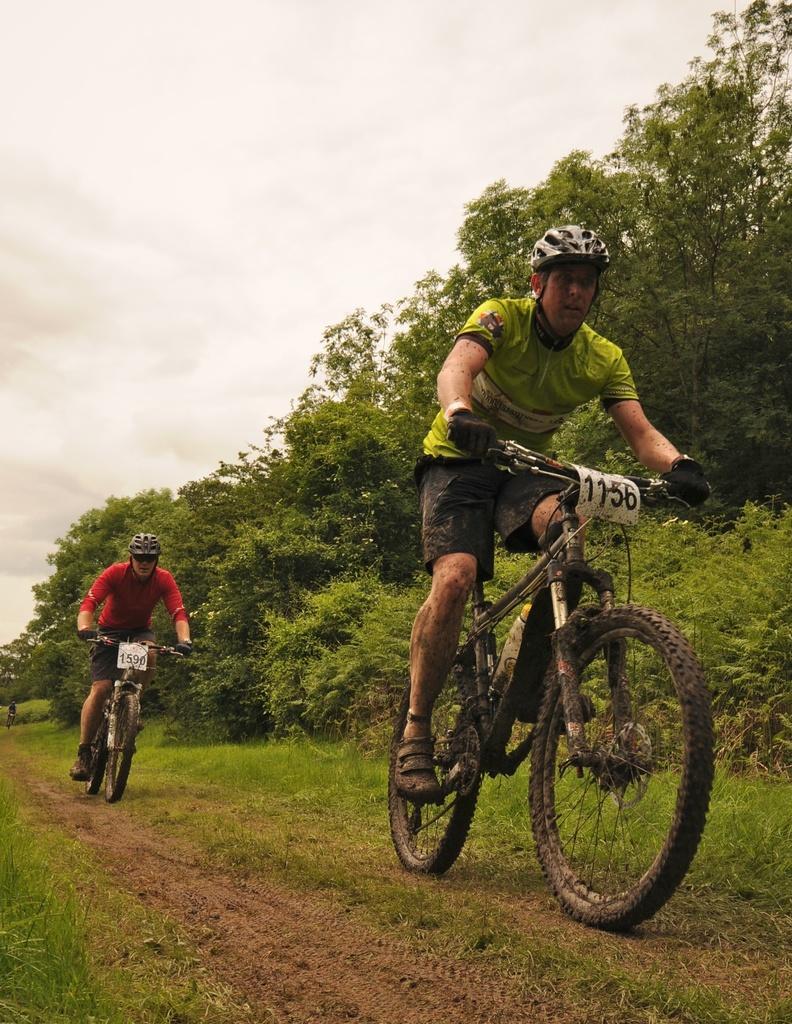Please provide a concise description of this image. In this image I see 2 men who are cycling on the path. In the background I see the grass, few plants, trees and the sky. 